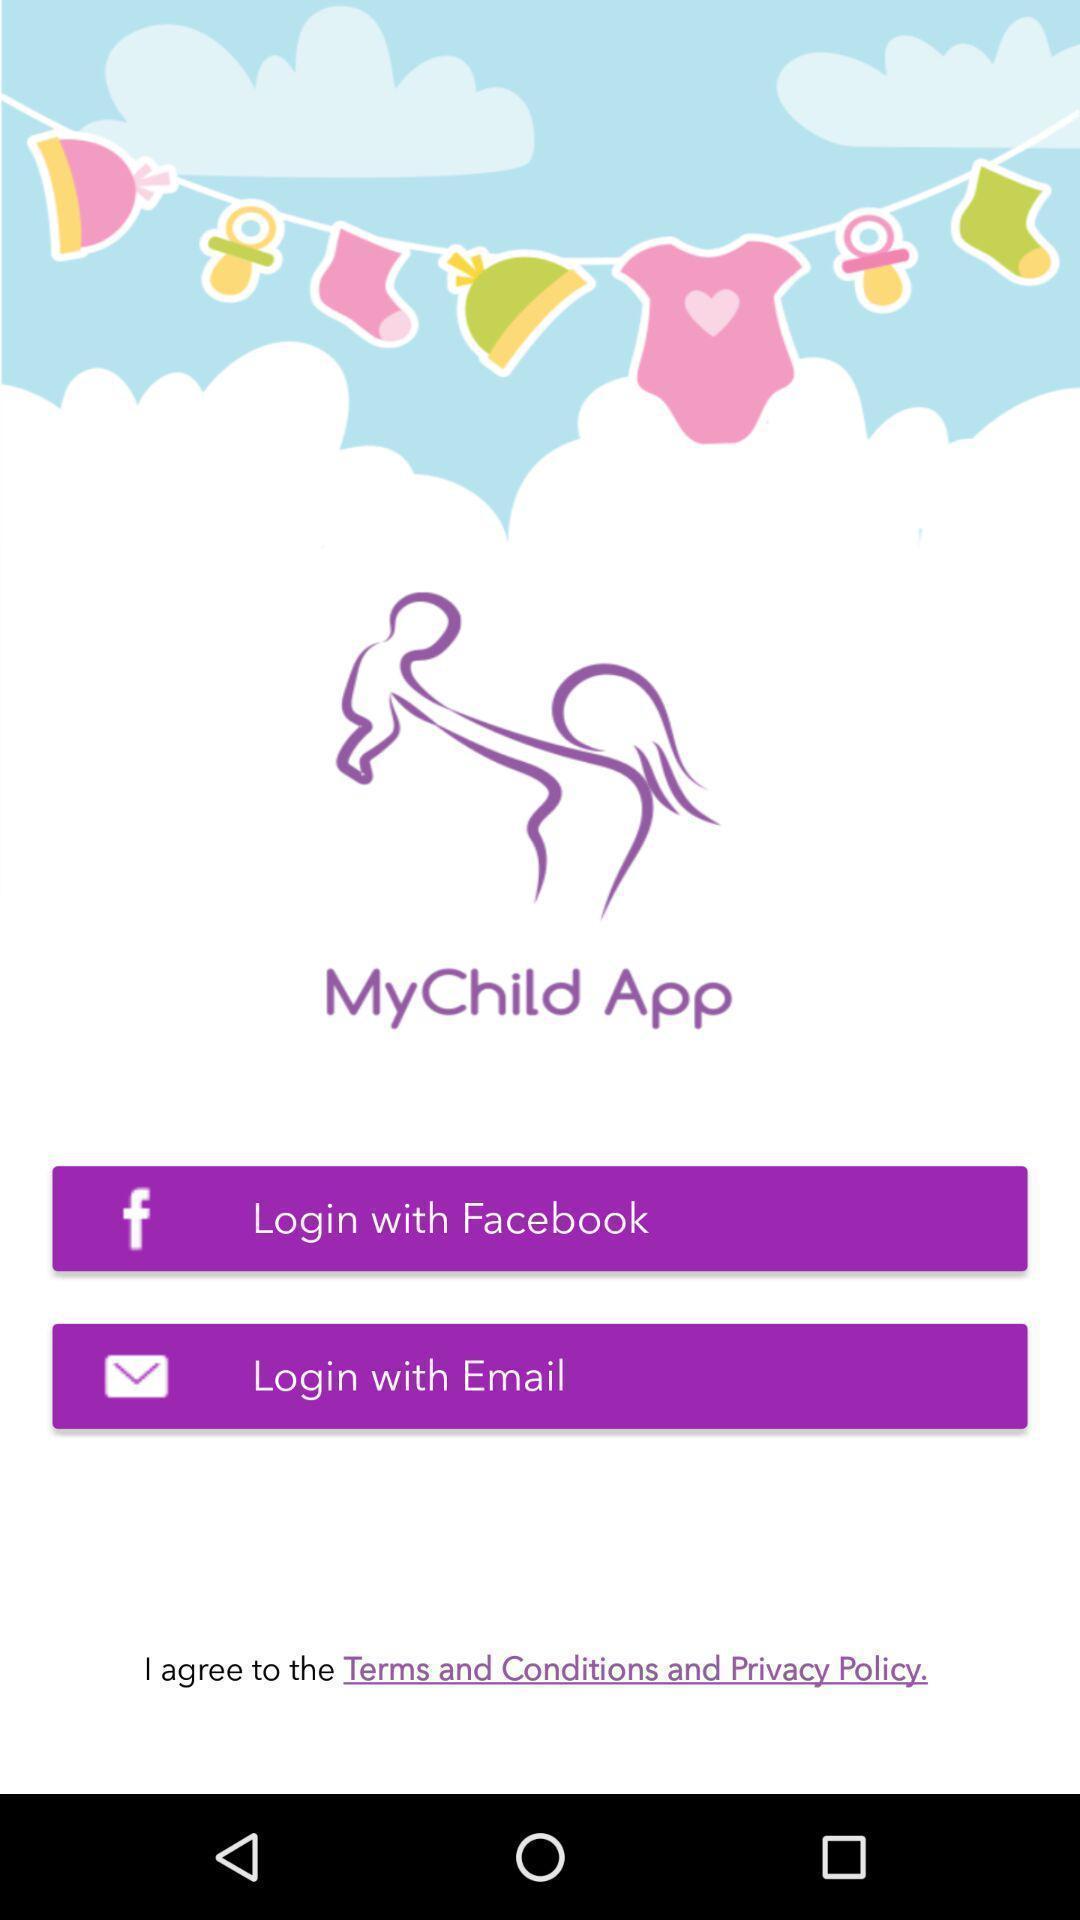Describe this image in words. Welcome page of a child growth app. 